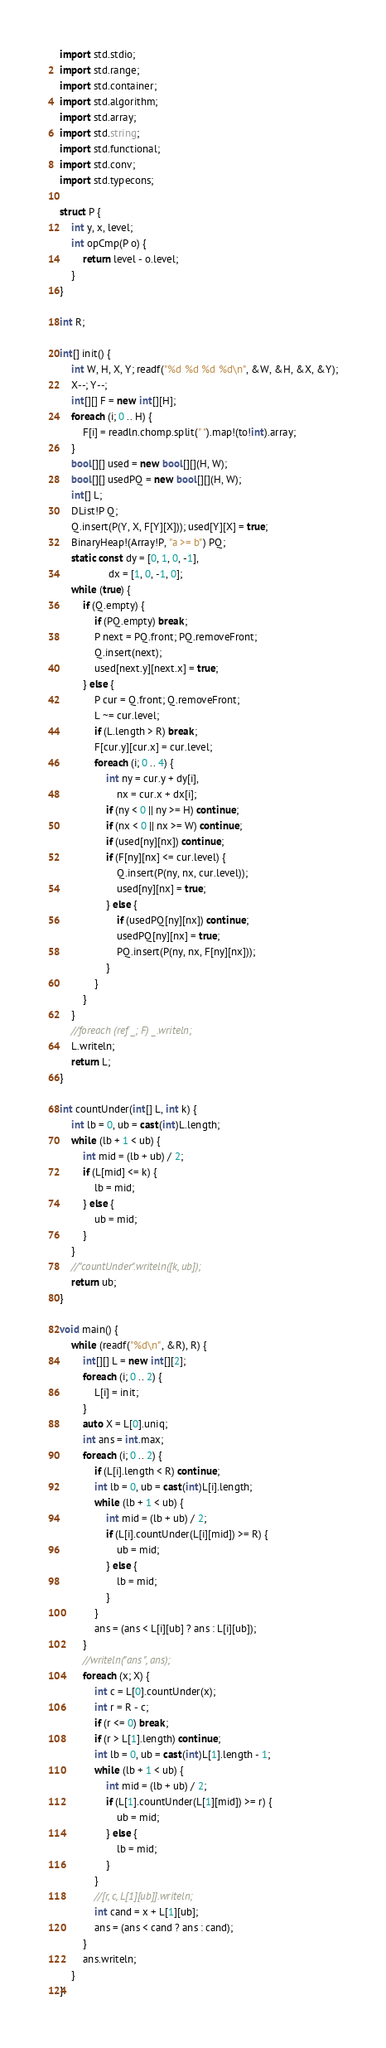<code> <loc_0><loc_0><loc_500><loc_500><_D_>import std.stdio;
import std.range;
import std.container;
import std.algorithm;
import std.array;
import std.string;
import std.functional;
import std.conv;
import std.typecons;

struct P {
    int y, x, level;
    int opCmp(P o) {
        return level - o.level;
    }
}

int R;

int[] init() {
    int W, H, X, Y; readf("%d %d %d %d\n", &W, &H, &X, &Y);
    X--; Y--;
    int[][] F = new int[][H];
    foreach (i; 0 .. H) {
        F[i] = readln.chomp.split(" ").map!(to!int).array;
    }
    bool[][] used = new bool[][](H, W);
    bool[][] usedPQ = new bool[][](H, W);
    int[] L;
    DList!P Q;
    Q.insert(P(Y, X, F[Y][X])); used[Y][X] = true;
    BinaryHeap!(Array!P, "a >= b") PQ;
    static const dy = [0, 1, 0, -1],
                 dx = [1, 0, -1, 0];
    while (true) {
        if (Q.empty) {
            if (PQ.empty) break;
            P next = PQ.front; PQ.removeFront;
            Q.insert(next);
            used[next.y][next.x] = true;
        } else {
            P cur = Q.front; Q.removeFront;
            L ~= cur.level;
            if (L.length > R) break;
            F[cur.y][cur.x] = cur.level;
            foreach (i; 0 .. 4) {
                int ny = cur.y + dy[i],
                    nx = cur.x + dx[i];
                if (ny < 0 || ny >= H) continue;
                if (nx < 0 || nx >= W) continue;
                if (used[ny][nx]) continue;
                if (F[ny][nx] <= cur.level) {
                    Q.insert(P(ny, nx, cur.level));
                    used[ny][nx] = true;
                } else {
                    if (usedPQ[ny][nx]) continue;
                    usedPQ[ny][nx] = true;
                    PQ.insert(P(ny, nx, F[ny][nx]));
                }
            }
        }
    }
    //foreach (ref _; F) _.writeln;
    L.writeln;
    return L;
}

int countUnder(int[] L, int k) {
    int lb = 0, ub = cast(int)L.length;
    while (lb + 1 < ub) {
        int mid = (lb + ub) / 2;
        if (L[mid] <= k) {
            lb = mid;
        } else {
            ub = mid;
        }
    }
    //"countUnder".writeln([k, ub]);
    return ub;
}

void main() {
    while (readf("%d\n", &R), R) {
        int[][] L = new int[][2];
        foreach (i; 0 .. 2) {
            L[i] = init;
        }
        auto X = L[0].uniq;
        int ans = int.max;
        foreach (i; 0 .. 2) {
            if (L[i].length < R) continue;
            int lb = 0, ub = cast(int)L[i].length;
            while (lb + 1 < ub) {
                int mid = (lb + ub) / 2;
                if (L[i].countUnder(L[i][mid]) >= R) {
                    ub = mid;
                } else {
                    lb = mid;
                }
            }
            ans = (ans < L[i][ub] ? ans : L[i][ub]);
        }
        //writeln("ans ", ans);
        foreach (x; X) {
            int c = L[0].countUnder(x);
            int r = R - c;
            if (r <= 0) break;
            if (r > L[1].length) continue;
            int lb = 0, ub = cast(int)L[1].length - 1;
            while (lb + 1 < ub) {
                int mid = (lb + ub) / 2;
                if (L[1].countUnder(L[1][mid]) >= r) {
                    ub = mid;
                } else {
                    lb = mid;
                }
            }
            //[r, c, L[1][ub]].writeln;
            int cand = x + L[1][ub];
            ans = (ans < cand ? ans : cand);
        }
        ans.writeln;
    }
}</code> 